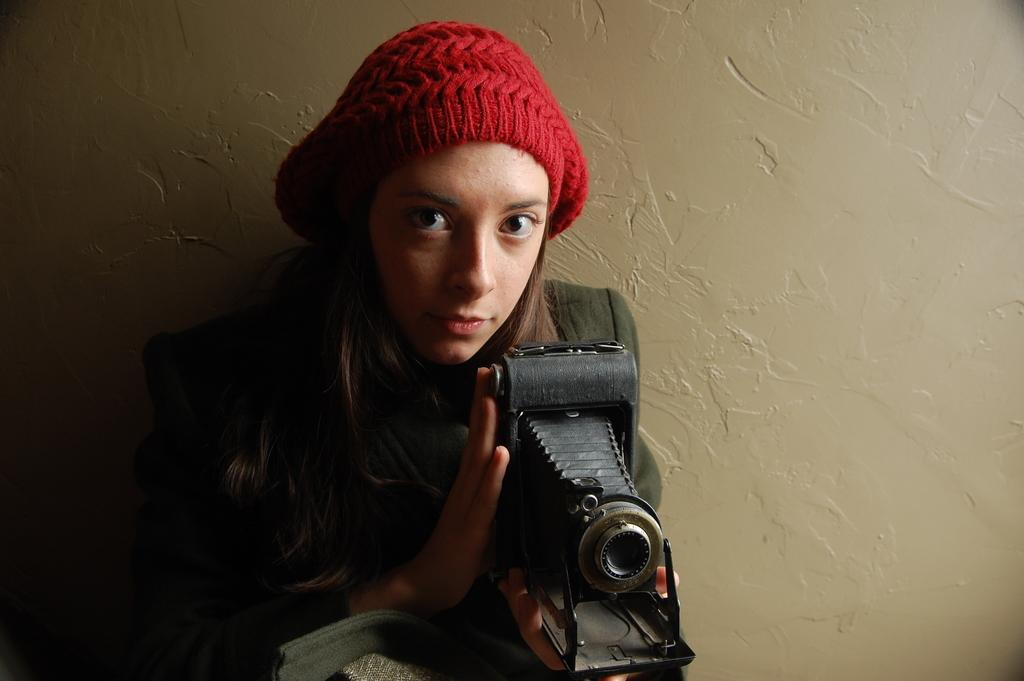Who is the main subject in the image? There is a woman in the image. What is the woman holding in the image? The woman is holding a camera. Where is the table located in the image? There is no table present in the image. What type of farm can be seen in the background of the image? There is no farm present in the image. 